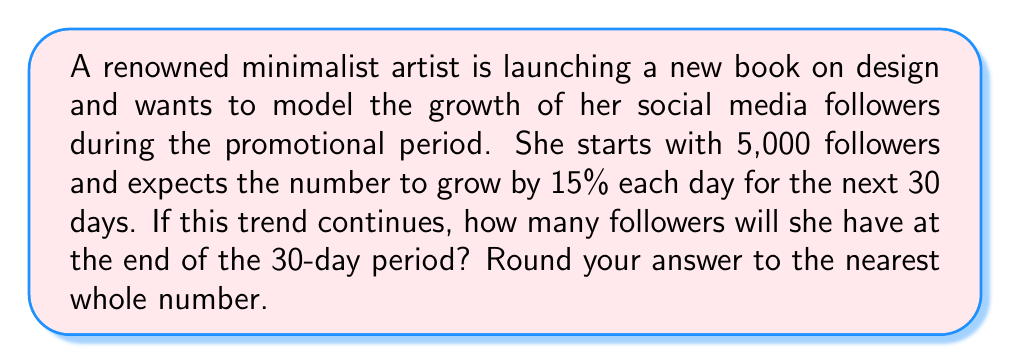Provide a solution to this math problem. Let's approach this step-by-step using an exponential growth model:

1) The initial number of followers is 5,000.
2) The daily growth rate is 15% or 0.15.
3) We need to find the number of followers after 30 days.

We can use the exponential growth formula:

$$ A = P(1 + r)^t $$

Where:
$A$ = Final amount
$P$ = Initial principal balance
$r$ = Daily growth rate (as a decimal)
$t$ = Number of days

Plugging in our values:

$$ A = 5000(1 + 0.15)^{30} $$

Now, let's calculate:

$$ A = 5000(1.15)^{30} $$
$$ A = 5000(66.2117) $$
$$ A = 331,058.5 $$

Rounding to the nearest whole number:

$$ A ≈ 331,059 $$
Answer: 331,059 followers 